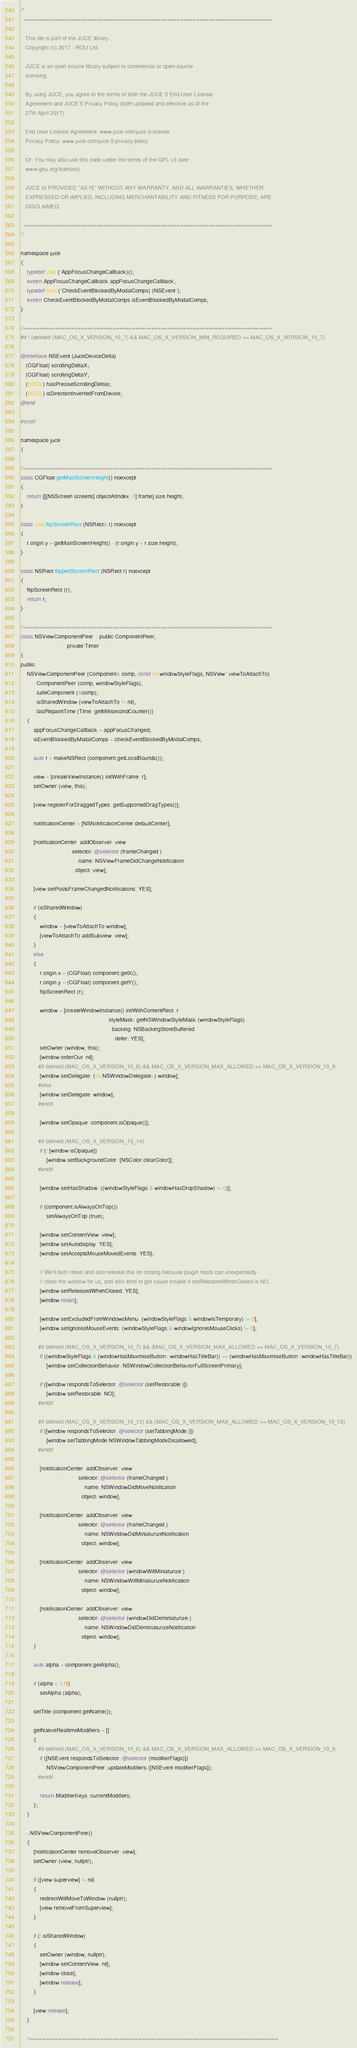Convert code to text. <code><loc_0><loc_0><loc_500><loc_500><_ObjectiveC_>/*
  ==============================================================================

   This file is part of the JUCE library.
   Copyright (c) 2017 - ROLI Ltd.

   JUCE is an open source library subject to commercial or open-source
   licensing.

   By using JUCE, you agree to the terms of both the JUCE 5 End-User License
   Agreement and JUCE 5 Privacy Policy (both updated and effective as of the
   27th April 2017).

   End User License Agreement: www.juce.com/juce-5-licence
   Privacy Policy: www.juce.com/juce-5-privacy-policy

   Or: You may also use this code under the terms of the GPL v3 (see
   www.gnu.org/licenses).

   JUCE IS PROVIDED "AS IS" WITHOUT ANY WARRANTY, AND ALL WARRANTIES, WHETHER
   EXPRESSED OR IMPLIED, INCLUDING MERCHANTABILITY AND FITNESS FOR PURPOSE, ARE
   DISCLAIMED.

  ==============================================================================
*/

namespace juce
{
    typedef void (*AppFocusChangeCallback)();
    extern AppFocusChangeCallback appFocusChangeCallback;
    typedef bool (*CheckEventBlockedByModalComps) (NSEvent*);
    extern CheckEventBlockedByModalComps isEventBlockedByModalComps;
}

//==============================================================================
#if ! (defined (MAC_OS_X_VERSION_10_7) && MAC_OS_X_VERSION_MIN_REQUIRED >= MAC_OS_X_VERSION_10_7)

@interface NSEvent (JuceDeviceDelta)
 - (CGFloat) scrollingDeltaX;
 - (CGFloat) scrollingDeltaY;
 - (BOOL) hasPreciseScrollingDeltas;
 - (BOOL) isDirectionInvertedFromDevice;
@end

#endif

namespace juce
{

//==============================================================================
static CGFloat getMainScreenHeight() noexcept
{
    return [[[NSScreen screens] objectAtIndex: 0] frame].size.height;
}

static void flipScreenRect (NSRect& r) noexcept
{
    r.origin.y = getMainScreenHeight() - (r.origin.y + r.size.height);
}

static NSRect flippedScreenRect (NSRect r) noexcept
{
    flipScreenRect (r);
    return r;
}

//==============================================================================
class NSViewComponentPeer  : public ComponentPeer,
                             private Timer
{
public:
    NSViewComponentPeer (Component& comp, const int windowStyleFlags, NSView* viewToAttachTo)
        : ComponentPeer (comp, windowStyleFlags),
          safeComponent (&comp),
          isSharedWindow (viewToAttachTo != nil),
          lastRepaintTime (Time::getMillisecondCounter())
    {
        appFocusChangeCallback = appFocusChanged;
        isEventBlockedByModalComps = checkEventBlockedByModalComps;

        auto r = makeNSRect (component.getLocalBounds());

        view = [createViewInstance() initWithFrame: r];
        setOwner (view, this);

        [view registerForDraggedTypes: getSupportedDragTypes()];

        notificationCenter = [NSNotificationCenter defaultCenter];

        [notificationCenter  addObserver: view
                                selector: @selector (frameChanged:)
                                    name: NSViewFrameDidChangeNotification
                                  object: view];

        [view setPostsFrameChangedNotifications: YES];

        if (isSharedWindow)
        {
            window = [viewToAttachTo window];
            [viewToAttachTo addSubview: view];
        }
        else
        {
            r.origin.x = (CGFloat) component.getX();
            r.origin.y = (CGFloat) component.getY();
            flipScreenRect (r);

            window = [createWindowInstance() initWithContentRect: r
                                                       styleMask: getNSWindowStyleMask (windowStyleFlags)
                                                         backing: NSBackingStoreBuffered
                                                           defer: YES];
            setOwner (window, this);
            [window orderOut: nil];
           #if defined (MAC_OS_X_VERSION_10_6) && MAC_OS_X_VERSION_MAX_ALLOWED >= MAC_OS_X_VERSION_10_6
            [window setDelegate: (id<NSWindowDelegate>) window];
           #else
            [window setDelegate: window];
           #endif

            [window setOpaque: component.isOpaque()];

           #if defined (MAC_OS_X_VERSION_10_14)
            if (! [window isOpaque])
                [window setBackgroundColor: [NSColor clearColor]];
           #endif

            [window setHasShadow: ((windowStyleFlags & windowHasDropShadow) != 0)];

            if (component.isAlwaysOnTop())
                setAlwaysOnTop (true);

            [window setContentView: view];
            [window setAutodisplay: YES];
            [window setAcceptsMouseMovedEvents: YES];

            // We'll both retain and also release this on closing because plugin hosts can unexpectedly
            // close the window for us, and also tend to get cause trouble if setReleasedWhenClosed is NO.
            [window setReleasedWhenClosed: YES];
            [window retain];

            [window setExcludedFromWindowsMenu: (windowStyleFlags & windowIsTemporary) != 0];
            [window setIgnoresMouseEvents: (windowStyleFlags & windowIgnoresMouseClicks) != 0];

           #if defined (MAC_OS_X_VERSION_10_7) && (MAC_OS_X_VERSION_MAX_ALLOWED >= MAC_OS_X_VERSION_10_7)
            if ((windowStyleFlags & (windowHasMaximiseButton | windowHasTitleBar)) == (windowHasMaximiseButton | windowHasTitleBar))
                [window setCollectionBehavior: NSWindowCollectionBehaviorFullScreenPrimary];

            if ([window respondsToSelector: @selector (setRestorable:)])
                [window setRestorable: NO];
           #endif

           #if defined (MAC_OS_X_VERSION_10_13) && (MAC_OS_X_VERSION_MAX_ALLOWED >= MAC_OS_X_VERSION_10_13)
            if ([window respondsToSelector: @selector (setTabbingMode:)])
                [window setTabbingMode:NSWindowTabbingModeDisallowed];
           #endif

            [notificationCenter  addObserver: view
                                    selector: @selector (frameChanged:)
                                        name: NSWindowDidMoveNotification
                                      object: window];

            [notificationCenter  addObserver: view
                                    selector: @selector (frameChanged:)
                                        name: NSWindowDidMiniaturizeNotification
                                      object: window];

            [notificationCenter  addObserver: view
                                    selector: @selector (windowWillMiniaturize:)
                                        name: NSWindowWillMiniaturizeNotification
                                      object: window];

            [notificationCenter  addObserver: view
                                    selector: @selector (windowDidDeminiaturize:)
                                        name: NSWindowDidDeminiaturizeNotification
                                      object: window];
        }

        auto alpha = component.getAlpha();

        if (alpha < 1.0f)
            setAlpha (alpha);

        setTitle (component.getName());

        getNativeRealtimeModifiers = []
        {
           #if defined (MAC_OS_X_VERSION_10_6) && MAC_OS_X_VERSION_MAX_ALLOWED >= MAC_OS_X_VERSION_10_6
            if ([NSEvent respondsToSelector: @selector (modifierFlags)])
                NSViewComponentPeer::updateModifiers ([NSEvent modifierFlags]);
           #endif

            return ModifierKeys::currentModifiers;
        };
    }

    ~NSViewComponentPeer()
    {
        [notificationCenter removeObserver: view];
        setOwner (view, nullptr);

        if ([view superview] != nil)
        {
            redirectWillMoveToWindow (nullptr);
            [view removeFromSuperview];
        }

        if (! isSharedWindow)
        {
            setOwner (window, nullptr);
            [window setContentView: nil];
            [window close];
            [window release];
        }

        [view release];
    }

    //==============================================================================</code> 